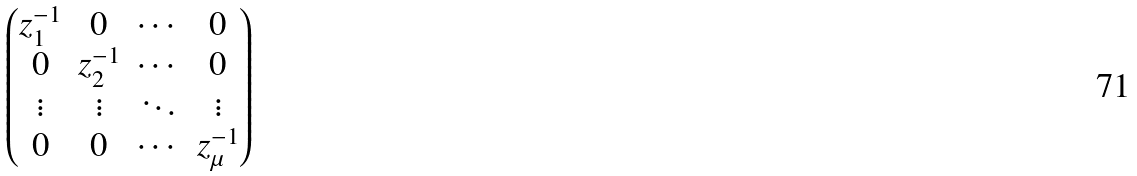<formula> <loc_0><loc_0><loc_500><loc_500>\begin{pmatrix} z _ { 1 } ^ { - 1 } & 0 & \cdots & 0 \\ 0 & z _ { 2 } ^ { - 1 } & \cdots & 0 \\ \vdots & \vdots & \ddots & \vdots \\ 0 & 0 & \cdots & z _ { \mu } ^ { - 1 } \end{pmatrix}</formula> 